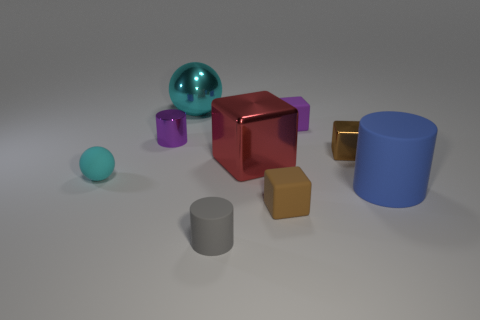What color is the small matte thing that is to the right of the red object and behind the brown rubber block?
Your response must be concise. Purple. What number of gray rubber cylinders have the same size as the brown matte cube?
Your response must be concise. 1. The shiny sphere that is the same color as the tiny rubber ball is what size?
Your answer should be very brief. Large. There is a object that is both in front of the tiny purple metallic thing and to the left of the large metallic sphere; what size is it?
Provide a short and direct response. Small. How many cyan metal objects are in front of the brown block in front of the blue rubber object on the right side of the tiny gray cylinder?
Make the answer very short. 0. Are there any cylinders of the same color as the tiny metallic block?
Provide a short and direct response. No. There is a ball that is the same size as the blue rubber cylinder; what color is it?
Keep it short and to the point. Cyan. What shape is the cyan object that is behind the tiny brown object on the right side of the small matte cube that is behind the big red metallic object?
Provide a succinct answer. Sphere. What number of large blocks are in front of the tiny matte block in front of the small purple metal object?
Your answer should be very brief. 0. Do the purple thing that is on the left side of the large red object and the red shiny object that is in front of the small purple cylinder have the same shape?
Offer a very short reply. No. 